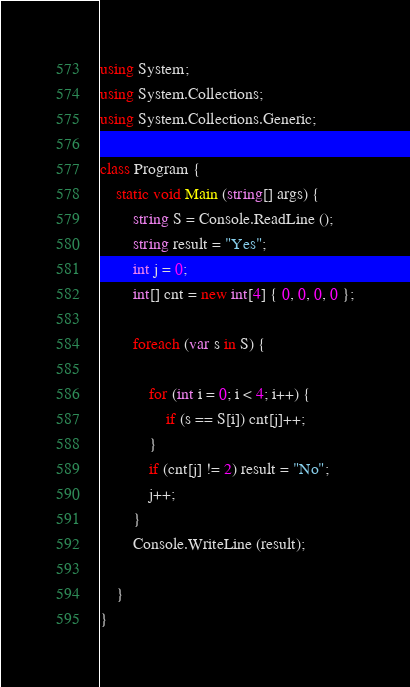<code> <loc_0><loc_0><loc_500><loc_500><_C#_>using System;
using System.Collections;
using System.Collections.Generic;

class Program {
    static void Main (string[] args) {
        string S = Console.ReadLine ();
        string result = "Yes";
        int j = 0;
        int[] cnt = new int[4] { 0, 0, 0, 0 };

        foreach (var s in S) {

            for (int i = 0; i < 4; i++) {
                if (s == S[i]) cnt[j]++;
            }
            if (cnt[j] != 2) result = "No";
            j++;
        }
        Console.WriteLine (result);

    }
}</code> 